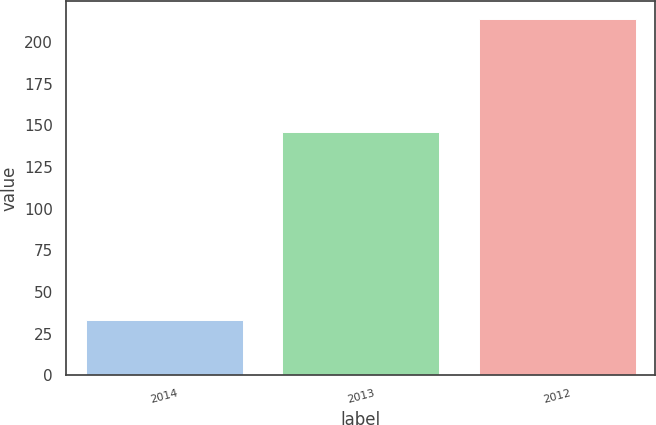Convert chart to OTSL. <chart><loc_0><loc_0><loc_500><loc_500><bar_chart><fcel>2014<fcel>2013<fcel>2012<nl><fcel>33<fcel>146<fcel>214<nl></chart> 